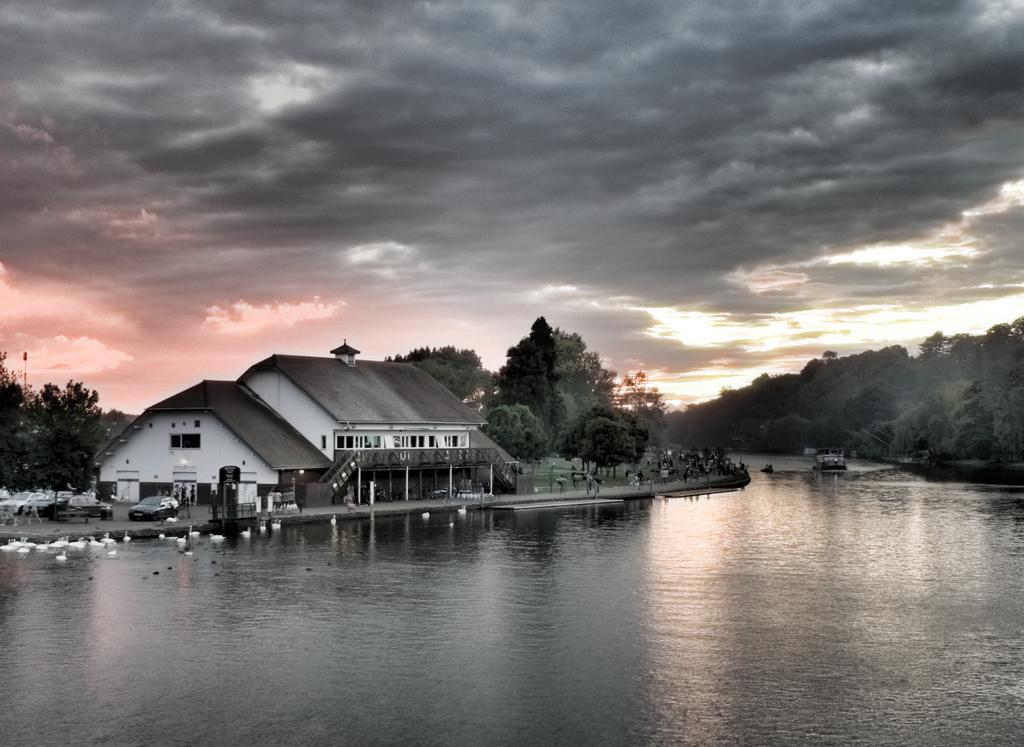Could you give a brief overview of what you see in this image? This picture is clicked outside. In the foreground we can see a water body and we can see the birds and the boats in the water body. On the left we can see the house and we can see the stairs, railing, metal rods, lights, vehicles, group of people and many other objects. In the background we can see the sky which is full of clouds and we can see the trees, plants and some objects. 